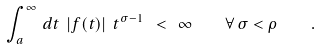Convert formula to latex. <formula><loc_0><loc_0><loc_500><loc_500>\int _ { a } ^ { \infty } \, d t \ | f ( t ) | \ t ^ { \sigma - 1 } \ < \ \infty \quad \forall \, \sigma < \rho \quad .</formula> 